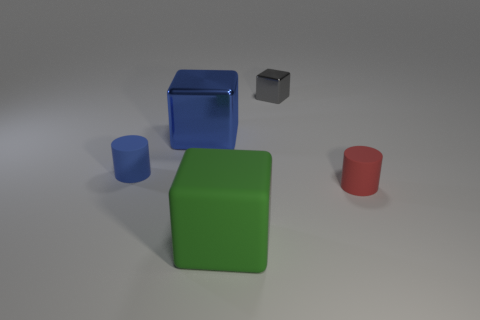Add 3 blue metallic blocks. How many objects exist? 8 Subtract all cubes. How many objects are left? 2 Add 1 red metallic balls. How many red metallic balls exist? 1 Subtract 0 red blocks. How many objects are left? 5 Subtract all red rubber cylinders. Subtract all large cyan matte spheres. How many objects are left? 4 Add 2 small red cylinders. How many small red cylinders are left? 3 